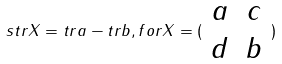<formula> <loc_0><loc_0><loc_500><loc_500>s t r X = t r a - t r b , f o r X = ( \begin{array} { c c } a & c \\ d & b \end{array} )</formula> 